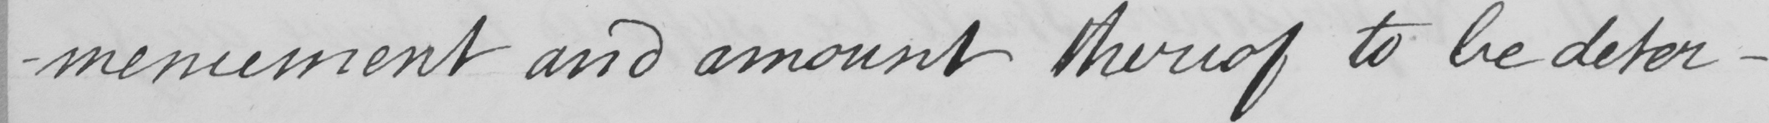What text is written in this handwritten line? -mencement and amount thereof to be deter- 